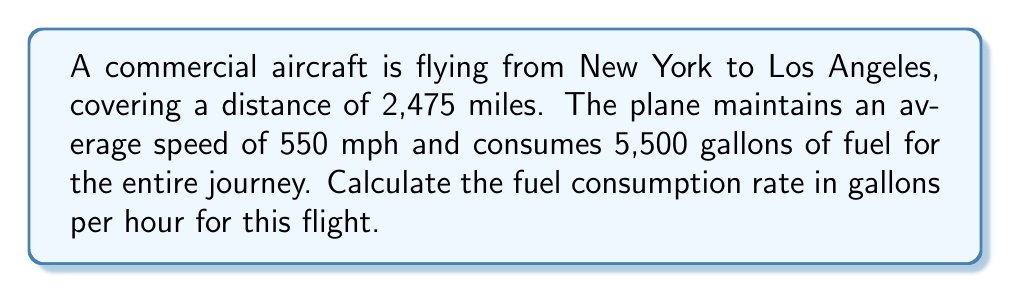Solve this math problem. To solve this problem, we'll follow these steps:

1. Calculate the flight duration:
   $$\text{Time} = \frac{\text{Distance}}{\text{Speed}}$$
   $$\text{Time} = \frac{2,475 \text{ miles}}{550 \text{ mph}} = 4.5 \text{ hours}$$

2. Calculate the fuel consumption rate:
   $$\text{Fuel Consumption Rate} = \frac{\text{Total Fuel Consumed}}{\text{Flight Duration}}$$
   $$\text{Fuel Consumption Rate} = \frac{5,500 \text{ gallons}}{4.5 \text{ hours}}$$

3. Perform the division:
   $$\text{Fuel Consumption Rate} = 1,222.22 \text{ gallons per hour}$$

Therefore, the fuel consumption rate for this aircraft during the flight is approximately 1,222.22 gallons per hour.
Answer: 1,222.22 gallons/hour 